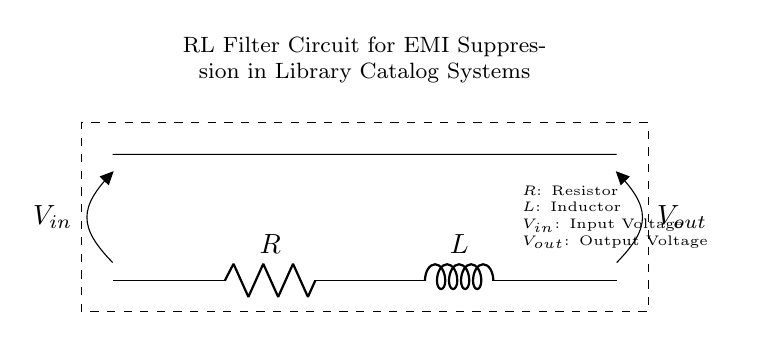What components are used in this circuit? The circuit consists of a resistor and an inductor, which can be identified by the labels R and L.
Answer: Resistor and Inductor What is the function of the resistor in this RL filter circuit? The resistor limits the current and contributes to the overall resistance in the circuit, which helps in the attenuation of high-frequency electromagnetic interference.
Answer: Attenuation What does the input voltage symbol represent? The input voltage symbol, labeled as V_in, represents the voltage supplied to the circuit for its operation.
Answer: V_in Which component is used for electromagnetic interference suppression in this circuit? The inductor is used in this RL filter configuration to suppress high-frequency noise, acting as a choke.
Answer: Inductor How does the output voltage relate to the input voltage in this circuit? The output voltage, labeled as V_out, can vary depending on the resistor and inductor values and is affected by the reduction of high-frequency signals due to the filter action.
Answer: V_out is lower than V_in What type of signal does this RL circuit typically filter? This RL circuit is designed to filter out high-frequency electromagnetic interference signals present in the input.
Answer: High-frequency signals What effects does the inductor create in this circuit? The inductor stores energy in its magnetic field when current flows through it and resists changes in current, which aids in filtering out unwanted frequencies.
Answer: Stores energy 